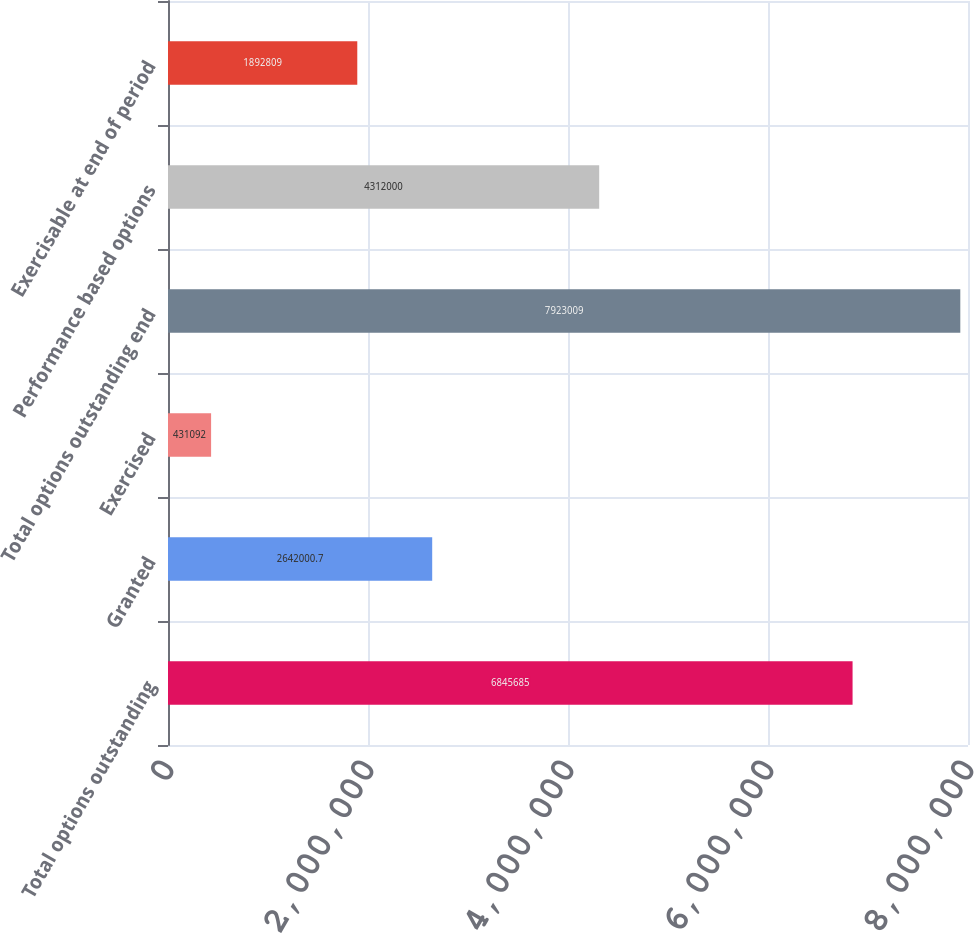Convert chart to OTSL. <chart><loc_0><loc_0><loc_500><loc_500><bar_chart><fcel>Total options outstanding<fcel>Granted<fcel>Exercised<fcel>Total options outstanding end<fcel>Performance based options<fcel>Exercisable at end of period<nl><fcel>6.84568e+06<fcel>2.642e+06<fcel>431092<fcel>7.92301e+06<fcel>4.312e+06<fcel>1.89281e+06<nl></chart> 